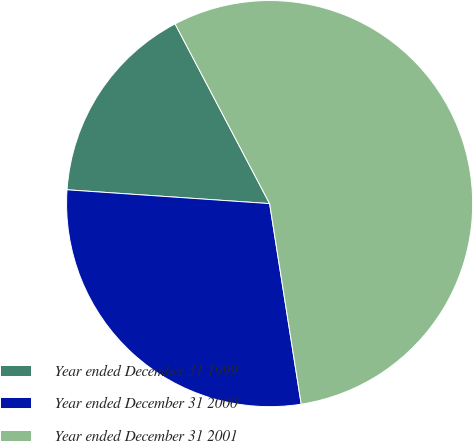Convert chart to OTSL. <chart><loc_0><loc_0><loc_500><loc_500><pie_chart><fcel>Year ended December 31 1999<fcel>Year ended December 31 2000<fcel>Year ended December 31 2001<nl><fcel>16.21%<fcel>28.57%<fcel>55.22%<nl></chart> 